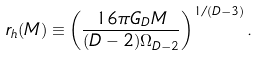Convert formula to latex. <formula><loc_0><loc_0><loc_500><loc_500>r _ { h } ( M ) \equiv \left ( \frac { 1 6 \pi G _ { D } M } { ( D - 2 ) \Omega _ { D - 2 } } \right ) ^ { 1 / ( D - 3 ) } .</formula> 